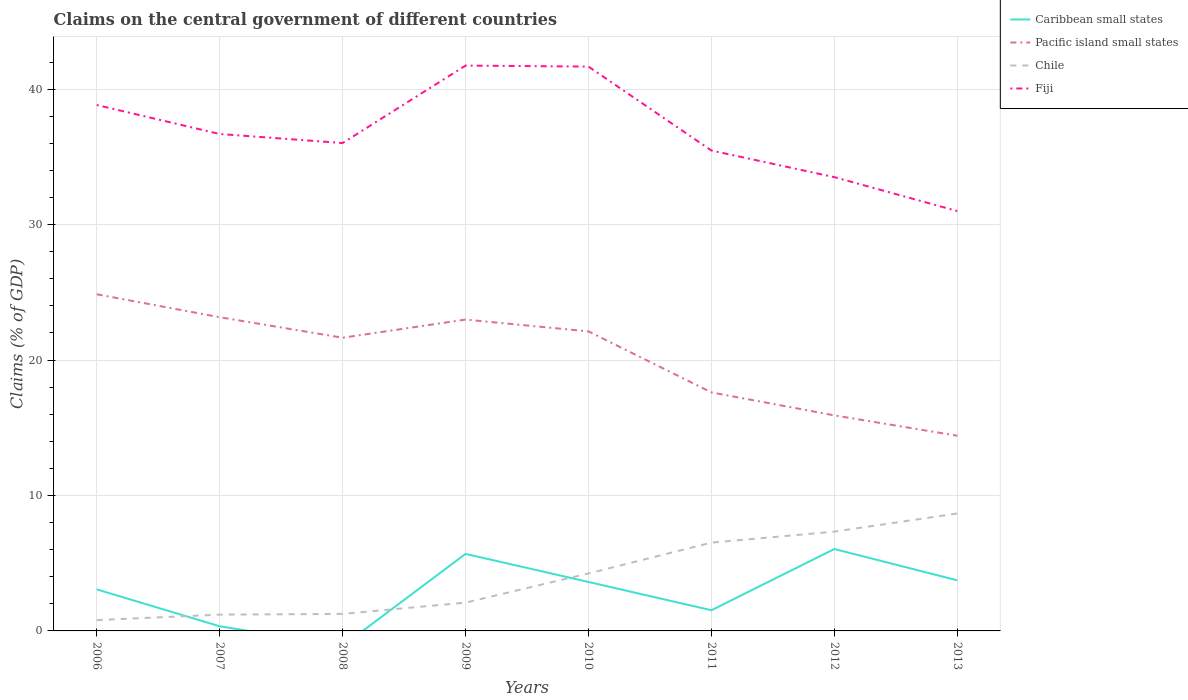Does the line corresponding to Pacific island small states intersect with the line corresponding to Caribbean small states?
Your response must be concise. No. Across all years, what is the maximum percentage of GDP claimed on the central government in Chile?
Your response must be concise. 0.8. What is the total percentage of GDP claimed on the central government in Chile in the graph?
Ensure brevity in your answer.  -6.13. What is the difference between the highest and the second highest percentage of GDP claimed on the central government in Caribbean small states?
Your answer should be compact. 6.05. How many lines are there?
Make the answer very short. 4. Are the values on the major ticks of Y-axis written in scientific E-notation?
Your answer should be very brief. No. Does the graph contain any zero values?
Provide a short and direct response. Yes. Where does the legend appear in the graph?
Your response must be concise. Top right. How many legend labels are there?
Offer a terse response. 4. What is the title of the graph?
Make the answer very short. Claims on the central government of different countries. Does "Iran" appear as one of the legend labels in the graph?
Offer a very short reply. No. What is the label or title of the Y-axis?
Your response must be concise. Claims (% of GDP). What is the Claims (% of GDP) in Caribbean small states in 2006?
Make the answer very short. 3.07. What is the Claims (% of GDP) of Pacific island small states in 2006?
Your answer should be compact. 24.86. What is the Claims (% of GDP) of Chile in 2006?
Provide a short and direct response. 0.8. What is the Claims (% of GDP) in Fiji in 2006?
Give a very brief answer. 38.83. What is the Claims (% of GDP) in Caribbean small states in 2007?
Your response must be concise. 0.34. What is the Claims (% of GDP) of Pacific island small states in 2007?
Make the answer very short. 23.16. What is the Claims (% of GDP) of Chile in 2007?
Provide a short and direct response. 1.2. What is the Claims (% of GDP) in Fiji in 2007?
Give a very brief answer. 36.69. What is the Claims (% of GDP) of Caribbean small states in 2008?
Your answer should be compact. 0. What is the Claims (% of GDP) in Pacific island small states in 2008?
Give a very brief answer. 21.65. What is the Claims (% of GDP) in Chile in 2008?
Ensure brevity in your answer.  1.26. What is the Claims (% of GDP) in Fiji in 2008?
Make the answer very short. 36.02. What is the Claims (% of GDP) in Caribbean small states in 2009?
Make the answer very short. 5.69. What is the Claims (% of GDP) in Pacific island small states in 2009?
Provide a succinct answer. 22.99. What is the Claims (% of GDP) in Chile in 2009?
Ensure brevity in your answer.  2.09. What is the Claims (% of GDP) of Fiji in 2009?
Your answer should be very brief. 41.74. What is the Claims (% of GDP) in Caribbean small states in 2010?
Your answer should be very brief. 3.61. What is the Claims (% of GDP) in Pacific island small states in 2010?
Offer a terse response. 22.12. What is the Claims (% of GDP) of Chile in 2010?
Make the answer very short. 4.24. What is the Claims (% of GDP) of Fiji in 2010?
Make the answer very short. 41.67. What is the Claims (% of GDP) of Caribbean small states in 2011?
Ensure brevity in your answer.  1.53. What is the Claims (% of GDP) in Pacific island small states in 2011?
Ensure brevity in your answer.  17.61. What is the Claims (% of GDP) in Chile in 2011?
Ensure brevity in your answer.  6.52. What is the Claims (% of GDP) in Fiji in 2011?
Provide a short and direct response. 35.47. What is the Claims (% of GDP) of Caribbean small states in 2012?
Your answer should be compact. 6.05. What is the Claims (% of GDP) of Pacific island small states in 2012?
Provide a short and direct response. 15.92. What is the Claims (% of GDP) in Chile in 2012?
Your answer should be very brief. 7.33. What is the Claims (% of GDP) in Fiji in 2012?
Your answer should be compact. 33.51. What is the Claims (% of GDP) in Caribbean small states in 2013?
Give a very brief answer. 3.74. What is the Claims (% of GDP) of Pacific island small states in 2013?
Ensure brevity in your answer.  14.41. What is the Claims (% of GDP) of Chile in 2013?
Ensure brevity in your answer.  8.67. What is the Claims (% of GDP) in Fiji in 2013?
Ensure brevity in your answer.  31. Across all years, what is the maximum Claims (% of GDP) in Caribbean small states?
Your answer should be very brief. 6.05. Across all years, what is the maximum Claims (% of GDP) of Pacific island small states?
Offer a very short reply. 24.86. Across all years, what is the maximum Claims (% of GDP) of Chile?
Provide a succinct answer. 8.67. Across all years, what is the maximum Claims (% of GDP) in Fiji?
Provide a succinct answer. 41.74. Across all years, what is the minimum Claims (% of GDP) of Pacific island small states?
Provide a succinct answer. 14.41. Across all years, what is the minimum Claims (% of GDP) of Chile?
Offer a terse response. 0.8. Across all years, what is the minimum Claims (% of GDP) of Fiji?
Provide a short and direct response. 31. What is the total Claims (% of GDP) in Caribbean small states in the graph?
Give a very brief answer. 24.02. What is the total Claims (% of GDP) in Pacific island small states in the graph?
Keep it short and to the point. 162.72. What is the total Claims (% of GDP) in Chile in the graph?
Offer a terse response. 32.12. What is the total Claims (% of GDP) in Fiji in the graph?
Your response must be concise. 294.95. What is the difference between the Claims (% of GDP) in Caribbean small states in 2006 and that in 2007?
Keep it short and to the point. 2.73. What is the difference between the Claims (% of GDP) of Pacific island small states in 2006 and that in 2007?
Keep it short and to the point. 1.69. What is the difference between the Claims (% of GDP) of Chile in 2006 and that in 2007?
Give a very brief answer. -0.41. What is the difference between the Claims (% of GDP) in Fiji in 2006 and that in 2007?
Make the answer very short. 2.14. What is the difference between the Claims (% of GDP) of Pacific island small states in 2006 and that in 2008?
Offer a very short reply. 3.21. What is the difference between the Claims (% of GDP) in Chile in 2006 and that in 2008?
Offer a very short reply. -0.46. What is the difference between the Claims (% of GDP) of Fiji in 2006 and that in 2008?
Make the answer very short. 2.81. What is the difference between the Claims (% of GDP) of Caribbean small states in 2006 and that in 2009?
Offer a terse response. -2.62. What is the difference between the Claims (% of GDP) of Pacific island small states in 2006 and that in 2009?
Offer a terse response. 1.87. What is the difference between the Claims (% of GDP) of Chile in 2006 and that in 2009?
Offer a terse response. -1.29. What is the difference between the Claims (% of GDP) of Fiji in 2006 and that in 2009?
Offer a terse response. -2.91. What is the difference between the Claims (% of GDP) of Caribbean small states in 2006 and that in 2010?
Your answer should be compact. -0.55. What is the difference between the Claims (% of GDP) of Pacific island small states in 2006 and that in 2010?
Give a very brief answer. 2.74. What is the difference between the Claims (% of GDP) in Chile in 2006 and that in 2010?
Keep it short and to the point. -3.45. What is the difference between the Claims (% of GDP) in Fiji in 2006 and that in 2010?
Offer a very short reply. -2.84. What is the difference between the Claims (% of GDP) of Caribbean small states in 2006 and that in 2011?
Your answer should be very brief. 1.54. What is the difference between the Claims (% of GDP) in Pacific island small states in 2006 and that in 2011?
Offer a terse response. 7.25. What is the difference between the Claims (% of GDP) in Chile in 2006 and that in 2011?
Keep it short and to the point. -5.72. What is the difference between the Claims (% of GDP) in Fiji in 2006 and that in 2011?
Provide a succinct answer. 3.36. What is the difference between the Claims (% of GDP) in Caribbean small states in 2006 and that in 2012?
Your answer should be compact. -2.98. What is the difference between the Claims (% of GDP) in Pacific island small states in 2006 and that in 2012?
Keep it short and to the point. 8.94. What is the difference between the Claims (% of GDP) of Chile in 2006 and that in 2012?
Offer a terse response. -6.53. What is the difference between the Claims (% of GDP) of Fiji in 2006 and that in 2012?
Keep it short and to the point. 5.33. What is the difference between the Claims (% of GDP) of Caribbean small states in 2006 and that in 2013?
Your answer should be compact. -0.67. What is the difference between the Claims (% of GDP) in Pacific island small states in 2006 and that in 2013?
Provide a succinct answer. 10.44. What is the difference between the Claims (% of GDP) in Chile in 2006 and that in 2013?
Offer a very short reply. -7.87. What is the difference between the Claims (% of GDP) of Fiji in 2006 and that in 2013?
Provide a succinct answer. 7.83. What is the difference between the Claims (% of GDP) of Pacific island small states in 2007 and that in 2008?
Keep it short and to the point. 1.52. What is the difference between the Claims (% of GDP) in Chile in 2007 and that in 2008?
Your answer should be compact. -0.05. What is the difference between the Claims (% of GDP) of Fiji in 2007 and that in 2008?
Ensure brevity in your answer.  0.67. What is the difference between the Claims (% of GDP) of Caribbean small states in 2007 and that in 2009?
Make the answer very short. -5.35. What is the difference between the Claims (% of GDP) of Pacific island small states in 2007 and that in 2009?
Give a very brief answer. 0.17. What is the difference between the Claims (% of GDP) in Chile in 2007 and that in 2009?
Ensure brevity in your answer.  -0.89. What is the difference between the Claims (% of GDP) of Fiji in 2007 and that in 2009?
Your answer should be compact. -5.05. What is the difference between the Claims (% of GDP) of Caribbean small states in 2007 and that in 2010?
Make the answer very short. -3.27. What is the difference between the Claims (% of GDP) in Pacific island small states in 2007 and that in 2010?
Your answer should be compact. 1.05. What is the difference between the Claims (% of GDP) in Chile in 2007 and that in 2010?
Provide a short and direct response. -3.04. What is the difference between the Claims (% of GDP) in Fiji in 2007 and that in 2010?
Your answer should be compact. -4.98. What is the difference between the Claims (% of GDP) in Caribbean small states in 2007 and that in 2011?
Your answer should be very brief. -1.19. What is the difference between the Claims (% of GDP) of Pacific island small states in 2007 and that in 2011?
Provide a succinct answer. 5.55. What is the difference between the Claims (% of GDP) in Chile in 2007 and that in 2011?
Offer a terse response. -5.32. What is the difference between the Claims (% of GDP) in Fiji in 2007 and that in 2011?
Provide a succinct answer. 1.22. What is the difference between the Claims (% of GDP) in Caribbean small states in 2007 and that in 2012?
Offer a terse response. -5.71. What is the difference between the Claims (% of GDP) in Pacific island small states in 2007 and that in 2012?
Keep it short and to the point. 7.25. What is the difference between the Claims (% of GDP) in Chile in 2007 and that in 2012?
Your answer should be very brief. -6.13. What is the difference between the Claims (% of GDP) of Fiji in 2007 and that in 2012?
Keep it short and to the point. 3.19. What is the difference between the Claims (% of GDP) in Caribbean small states in 2007 and that in 2013?
Ensure brevity in your answer.  -3.39. What is the difference between the Claims (% of GDP) in Pacific island small states in 2007 and that in 2013?
Provide a short and direct response. 8.75. What is the difference between the Claims (% of GDP) of Chile in 2007 and that in 2013?
Ensure brevity in your answer.  -7.47. What is the difference between the Claims (% of GDP) in Fiji in 2007 and that in 2013?
Your answer should be very brief. 5.69. What is the difference between the Claims (% of GDP) of Pacific island small states in 2008 and that in 2009?
Offer a terse response. -1.34. What is the difference between the Claims (% of GDP) in Chile in 2008 and that in 2009?
Offer a terse response. -0.83. What is the difference between the Claims (% of GDP) of Fiji in 2008 and that in 2009?
Keep it short and to the point. -5.72. What is the difference between the Claims (% of GDP) in Pacific island small states in 2008 and that in 2010?
Keep it short and to the point. -0.47. What is the difference between the Claims (% of GDP) in Chile in 2008 and that in 2010?
Your response must be concise. -2.99. What is the difference between the Claims (% of GDP) in Fiji in 2008 and that in 2010?
Your answer should be very brief. -5.65. What is the difference between the Claims (% of GDP) in Pacific island small states in 2008 and that in 2011?
Keep it short and to the point. 4.04. What is the difference between the Claims (% of GDP) of Chile in 2008 and that in 2011?
Offer a very short reply. -5.26. What is the difference between the Claims (% of GDP) in Fiji in 2008 and that in 2011?
Keep it short and to the point. 0.55. What is the difference between the Claims (% of GDP) in Pacific island small states in 2008 and that in 2012?
Keep it short and to the point. 5.73. What is the difference between the Claims (% of GDP) in Chile in 2008 and that in 2012?
Ensure brevity in your answer.  -6.07. What is the difference between the Claims (% of GDP) in Fiji in 2008 and that in 2012?
Offer a very short reply. 2.52. What is the difference between the Claims (% of GDP) of Pacific island small states in 2008 and that in 2013?
Ensure brevity in your answer.  7.24. What is the difference between the Claims (% of GDP) in Chile in 2008 and that in 2013?
Provide a succinct answer. -7.41. What is the difference between the Claims (% of GDP) in Fiji in 2008 and that in 2013?
Provide a succinct answer. 5.02. What is the difference between the Claims (% of GDP) of Caribbean small states in 2009 and that in 2010?
Make the answer very short. 2.07. What is the difference between the Claims (% of GDP) of Pacific island small states in 2009 and that in 2010?
Keep it short and to the point. 0.87. What is the difference between the Claims (% of GDP) in Chile in 2009 and that in 2010?
Provide a succinct answer. -2.15. What is the difference between the Claims (% of GDP) in Fiji in 2009 and that in 2010?
Your answer should be compact. 0.07. What is the difference between the Claims (% of GDP) of Caribbean small states in 2009 and that in 2011?
Keep it short and to the point. 4.16. What is the difference between the Claims (% of GDP) of Pacific island small states in 2009 and that in 2011?
Provide a succinct answer. 5.38. What is the difference between the Claims (% of GDP) in Chile in 2009 and that in 2011?
Keep it short and to the point. -4.43. What is the difference between the Claims (% of GDP) in Fiji in 2009 and that in 2011?
Keep it short and to the point. 6.27. What is the difference between the Claims (% of GDP) of Caribbean small states in 2009 and that in 2012?
Offer a terse response. -0.36. What is the difference between the Claims (% of GDP) in Pacific island small states in 2009 and that in 2012?
Ensure brevity in your answer.  7.07. What is the difference between the Claims (% of GDP) of Chile in 2009 and that in 2012?
Your answer should be very brief. -5.24. What is the difference between the Claims (% of GDP) in Fiji in 2009 and that in 2012?
Your response must be concise. 8.24. What is the difference between the Claims (% of GDP) of Caribbean small states in 2009 and that in 2013?
Give a very brief answer. 1.95. What is the difference between the Claims (% of GDP) in Pacific island small states in 2009 and that in 2013?
Make the answer very short. 8.58. What is the difference between the Claims (% of GDP) of Chile in 2009 and that in 2013?
Provide a succinct answer. -6.58. What is the difference between the Claims (% of GDP) in Fiji in 2009 and that in 2013?
Offer a terse response. 10.74. What is the difference between the Claims (% of GDP) of Caribbean small states in 2010 and that in 2011?
Offer a very short reply. 2.09. What is the difference between the Claims (% of GDP) in Pacific island small states in 2010 and that in 2011?
Give a very brief answer. 4.5. What is the difference between the Claims (% of GDP) in Chile in 2010 and that in 2011?
Keep it short and to the point. -2.28. What is the difference between the Claims (% of GDP) of Fiji in 2010 and that in 2011?
Provide a short and direct response. 6.2. What is the difference between the Claims (% of GDP) in Caribbean small states in 2010 and that in 2012?
Your response must be concise. -2.43. What is the difference between the Claims (% of GDP) of Pacific island small states in 2010 and that in 2012?
Your answer should be very brief. 6.2. What is the difference between the Claims (% of GDP) in Chile in 2010 and that in 2012?
Offer a terse response. -3.09. What is the difference between the Claims (% of GDP) of Fiji in 2010 and that in 2012?
Provide a succinct answer. 8.16. What is the difference between the Claims (% of GDP) of Caribbean small states in 2010 and that in 2013?
Give a very brief answer. -0.12. What is the difference between the Claims (% of GDP) in Pacific island small states in 2010 and that in 2013?
Ensure brevity in your answer.  7.7. What is the difference between the Claims (% of GDP) of Chile in 2010 and that in 2013?
Offer a very short reply. -4.43. What is the difference between the Claims (% of GDP) of Fiji in 2010 and that in 2013?
Provide a short and direct response. 10.67. What is the difference between the Claims (% of GDP) of Caribbean small states in 2011 and that in 2012?
Your response must be concise. -4.52. What is the difference between the Claims (% of GDP) in Pacific island small states in 2011 and that in 2012?
Offer a very short reply. 1.7. What is the difference between the Claims (% of GDP) of Chile in 2011 and that in 2012?
Your answer should be compact. -0.81. What is the difference between the Claims (% of GDP) in Fiji in 2011 and that in 2012?
Ensure brevity in your answer.  1.97. What is the difference between the Claims (% of GDP) of Caribbean small states in 2011 and that in 2013?
Offer a very short reply. -2.21. What is the difference between the Claims (% of GDP) of Pacific island small states in 2011 and that in 2013?
Provide a short and direct response. 3.2. What is the difference between the Claims (% of GDP) in Chile in 2011 and that in 2013?
Make the answer very short. -2.15. What is the difference between the Claims (% of GDP) in Fiji in 2011 and that in 2013?
Give a very brief answer. 4.47. What is the difference between the Claims (% of GDP) of Caribbean small states in 2012 and that in 2013?
Keep it short and to the point. 2.31. What is the difference between the Claims (% of GDP) of Pacific island small states in 2012 and that in 2013?
Make the answer very short. 1.5. What is the difference between the Claims (% of GDP) in Chile in 2012 and that in 2013?
Provide a short and direct response. -1.34. What is the difference between the Claims (% of GDP) in Fiji in 2012 and that in 2013?
Your answer should be compact. 2.5. What is the difference between the Claims (% of GDP) in Caribbean small states in 2006 and the Claims (% of GDP) in Pacific island small states in 2007?
Give a very brief answer. -20.1. What is the difference between the Claims (% of GDP) in Caribbean small states in 2006 and the Claims (% of GDP) in Chile in 2007?
Provide a short and direct response. 1.86. What is the difference between the Claims (% of GDP) in Caribbean small states in 2006 and the Claims (% of GDP) in Fiji in 2007?
Offer a very short reply. -33.63. What is the difference between the Claims (% of GDP) of Pacific island small states in 2006 and the Claims (% of GDP) of Chile in 2007?
Offer a very short reply. 23.65. What is the difference between the Claims (% of GDP) of Pacific island small states in 2006 and the Claims (% of GDP) of Fiji in 2007?
Keep it short and to the point. -11.84. What is the difference between the Claims (% of GDP) in Chile in 2006 and the Claims (% of GDP) in Fiji in 2007?
Your response must be concise. -35.9. What is the difference between the Claims (% of GDP) in Caribbean small states in 2006 and the Claims (% of GDP) in Pacific island small states in 2008?
Give a very brief answer. -18.58. What is the difference between the Claims (% of GDP) in Caribbean small states in 2006 and the Claims (% of GDP) in Chile in 2008?
Offer a very short reply. 1.81. What is the difference between the Claims (% of GDP) of Caribbean small states in 2006 and the Claims (% of GDP) of Fiji in 2008?
Your response must be concise. -32.96. What is the difference between the Claims (% of GDP) in Pacific island small states in 2006 and the Claims (% of GDP) in Chile in 2008?
Your answer should be very brief. 23.6. What is the difference between the Claims (% of GDP) in Pacific island small states in 2006 and the Claims (% of GDP) in Fiji in 2008?
Provide a short and direct response. -11.17. What is the difference between the Claims (% of GDP) of Chile in 2006 and the Claims (% of GDP) of Fiji in 2008?
Give a very brief answer. -35.23. What is the difference between the Claims (% of GDP) of Caribbean small states in 2006 and the Claims (% of GDP) of Pacific island small states in 2009?
Give a very brief answer. -19.92. What is the difference between the Claims (% of GDP) in Caribbean small states in 2006 and the Claims (% of GDP) in Chile in 2009?
Ensure brevity in your answer.  0.98. What is the difference between the Claims (% of GDP) of Caribbean small states in 2006 and the Claims (% of GDP) of Fiji in 2009?
Offer a terse response. -38.68. What is the difference between the Claims (% of GDP) in Pacific island small states in 2006 and the Claims (% of GDP) in Chile in 2009?
Offer a very short reply. 22.77. What is the difference between the Claims (% of GDP) of Pacific island small states in 2006 and the Claims (% of GDP) of Fiji in 2009?
Make the answer very short. -16.89. What is the difference between the Claims (% of GDP) of Chile in 2006 and the Claims (% of GDP) of Fiji in 2009?
Your answer should be very brief. -40.95. What is the difference between the Claims (% of GDP) of Caribbean small states in 2006 and the Claims (% of GDP) of Pacific island small states in 2010?
Provide a succinct answer. -19.05. What is the difference between the Claims (% of GDP) of Caribbean small states in 2006 and the Claims (% of GDP) of Chile in 2010?
Ensure brevity in your answer.  -1.18. What is the difference between the Claims (% of GDP) of Caribbean small states in 2006 and the Claims (% of GDP) of Fiji in 2010?
Your response must be concise. -38.6. What is the difference between the Claims (% of GDP) of Pacific island small states in 2006 and the Claims (% of GDP) of Chile in 2010?
Your answer should be very brief. 20.61. What is the difference between the Claims (% of GDP) of Pacific island small states in 2006 and the Claims (% of GDP) of Fiji in 2010?
Ensure brevity in your answer.  -16.81. What is the difference between the Claims (% of GDP) of Chile in 2006 and the Claims (% of GDP) of Fiji in 2010?
Give a very brief answer. -40.87. What is the difference between the Claims (% of GDP) in Caribbean small states in 2006 and the Claims (% of GDP) in Pacific island small states in 2011?
Offer a terse response. -14.54. What is the difference between the Claims (% of GDP) in Caribbean small states in 2006 and the Claims (% of GDP) in Chile in 2011?
Provide a succinct answer. -3.45. What is the difference between the Claims (% of GDP) of Caribbean small states in 2006 and the Claims (% of GDP) of Fiji in 2011?
Offer a terse response. -32.41. What is the difference between the Claims (% of GDP) of Pacific island small states in 2006 and the Claims (% of GDP) of Chile in 2011?
Give a very brief answer. 18.34. What is the difference between the Claims (% of GDP) of Pacific island small states in 2006 and the Claims (% of GDP) of Fiji in 2011?
Provide a succinct answer. -10.62. What is the difference between the Claims (% of GDP) in Chile in 2006 and the Claims (% of GDP) in Fiji in 2011?
Your response must be concise. -34.67. What is the difference between the Claims (% of GDP) of Caribbean small states in 2006 and the Claims (% of GDP) of Pacific island small states in 2012?
Provide a short and direct response. -12.85. What is the difference between the Claims (% of GDP) in Caribbean small states in 2006 and the Claims (% of GDP) in Chile in 2012?
Offer a terse response. -4.26. What is the difference between the Claims (% of GDP) in Caribbean small states in 2006 and the Claims (% of GDP) in Fiji in 2012?
Make the answer very short. -30.44. What is the difference between the Claims (% of GDP) of Pacific island small states in 2006 and the Claims (% of GDP) of Chile in 2012?
Provide a short and direct response. 17.53. What is the difference between the Claims (% of GDP) in Pacific island small states in 2006 and the Claims (% of GDP) in Fiji in 2012?
Your answer should be compact. -8.65. What is the difference between the Claims (% of GDP) of Chile in 2006 and the Claims (% of GDP) of Fiji in 2012?
Offer a very short reply. -32.71. What is the difference between the Claims (% of GDP) of Caribbean small states in 2006 and the Claims (% of GDP) of Pacific island small states in 2013?
Provide a succinct answer. -11.35. What is the difference between the Claims (% of GDP) in Caribbean small states in 2006 and the Claims (% of GDP) in Chile in 2013?
Keep it short and to the point. -5.6. What is the difference between the Claims (% of GDP) of Caribbean small states in 2006 and the Claims (% of GDP) of Fiji in 2013?
Provide a succinct answer. -27.94. What is the difference between the Claims (% of GDP) of Pacific island small states in 2006 and the Claims (% of GDP) of Chile in 2013?
Offer a very short reply. 16.19. What is the difference between the Claims (% of GDP) in Pacific island small states in 2006 and the Claims (% of GDP) in Fiji in 2013?
Keep it short and to the point. -6.15. What is the difference between the Claims (% of GDP) in Chile in 2006 and the Claims (% of GDP) in Fiji in 2013?
Provide a short and direct response. -30.21. What is the difference between the Claims (% of GDP) of Caribbean small states in 2007 and the Claims (% of GDP) of Pacific island small states in 2008?
Keep it short and to the point. -21.31. What is the difference between the Claims (% of GDP) of Caribbean small states in 2007 and the Claims (% of GDP) of Chile in 2008?
Your answer should be very brief. -0.92. What is the difference between the Claims (% of GDP) of Caribbean small states in 2007 and the Claims (% of GDP) of Fiji in 2008?
Provide a short and direct response. -35.68. What is the difference between the Claims (% of GDP) in Pacific island small states in 2007 and the Claims (% of GDP) in Chile in 2008?
Offer a very short reply. 21.91. What is the difference between the Claims (% of GDP) in Pacific island small states in 2007 and the Claims (% of GDP) in Fiji in 2008?
Give a very brief answer. -12.86. What is the difference between the Claims (% of GDP) of Chile in 2007 and the Claims (% of GDP) of Fiji in 2008?
Offer a very short reply. -34.82. What is the difference between the Claims (% of GDP) of Caribbean small states in 2007 and the Claims (% of GDP) of Pacific island small states in 2009?
Make the answer very short. -22.65. What is the difference between the Claims (% of GDP) of Caribbean small states in 2007 and the Claims (% of GDP) of Chile in 2009?
Your answer should be compact. -1.75. What is the difference between the Claims (% of GDP) in Caribbean small states in 2007 and the Claims (% of GDP) in Fiji in 2009?
Provide a succinct answer. -41.4. What is the difference between the Claims (% of GDP) in Pacific island small states in 2007 and the Claims (% of GDP) in Chile in 2009?
Your response must be concise. 21.07. What is the difference between the Claims (% of GDP) of Pacific island small states in 2007 and the Claims (% of GDP) of Fiji in 2009?
Make the answer very short. -18.58. What is the difference between the Claims (% of GDP) in Chile in 2007 and the Claims (% of GDP) in Fiji in 2009?
Your answer should be compact. -40.54. What is the difference between the Claims (% of GDP) of Caribbean small states in 2007 and the Claims (% of GDP) of Pacific island small states in 2010?
Provide a succinct answer. -21.78. What is the difference between the Claims (% of GDP) in Caribbean small states in 2007 and the Claims (% of GDP) in Chile in 2010?
Make the answer very short. -3.9. What is the difference between the Claims (% of GDP) in Caribbean small states in 2007 and the Claims (% of GDP) in Fiji in 2010?
Make the answer very short. -41.33. What is the difference between the Claims (% of GDP) in Pacific island small states in 2007 and the Claims (% of GDP) in Chile in 2010?
Offer a very short reply. 18.92. What is the difference between the Claims (% of GDP) in Pacific island small states in 2007 and the Claims (% of GDP) in Fiji in 2010?
Keep it short and to the point. -18.51. What is the difference between the Claims (% of GDP) in Chile in 2007 and the Claims (% of GDP) in Fiji in 2010?
Keep it short and to the point. -40.47. What is the difference between the Claims (% of GDP) of Caribbean small states in 2007 and the Claims (% of GDP) of Pacific island small states in 2011?
Ensure brevity in your answer.  -17.27. What is the difference between the Claims (% of GDP) of Caribbean small states in 2007 and the Claims (% of GDP) of Chile in 2011?
Offer a terse response. -6.18. What is the difference between the Claims (% of GDP) of Caribbean small states in 2007 and the Claims (% of GDP) of Fiji in 2011?
Your answer should be compact. -35.13. What is the difference between the Claims (% of GDP) in Pacific island small states in 2007 and the Claims (% of GDP) in Chile in 2011?
Provide a succinct answer. 16.64. What is the difference between the Claims (% of GDP) of Pacific island small states in 2007 and the Claims (% of GDP) of Fiji in 2011?
Your answer should be compact. -12.31. What is the difference between the Claims (% of GDP) in Chile in 2007 and the Claims (% of GDP) in Fiji in 2011?
Provide a short and direct response. -34.27. What is the difference between the Claims (% of GDP) of Caribbean small states in 2007 and the Claims (% of GDP) of Pacific island small states in 2012?
Your response must be concise. -15.57. What is the difference between the Claims (% of GDP) of Caribbean small states in 2007 and the Claims (% of GDP) of Chile in 2012?
Offer a terse response. -6.99. What is the difference between the Claims (% of GDP) in Caribbean small states in 2007 and the Claims (% of GDP) in Fiji in 2012?
Ensure brevity in your answer.  -33.16. What is the difference between the Claims (% of GDP) of Pacific island small states in 2007 and the Claims (% of GDP) of Chile in 2012?
Offer a very short reply. 15.83. What is the difference between the Claims (% of GDP) of Pacific island small states in 2007 and the Claims (% of GDP) of Fiji in 2012?
Make the answer very short. -10.34. What is the difference between the Claims (% of GDP) in Chile in 2007 and the Claims (% of GDP) in Fiji in 2012?
Provide a succinct answer. -32.3. What is the difference between the Claims (% of GDP) of Caribbean small states in 2007 and the Claims (% of GDP) of Pacific island small states in 2013?
Ensure brevity in your answer.  -14.07. What is the difference between the Claims (% of GDP) of Caribbean small states in 2007 and the Claims (% of GDP) of Chile in 2013?
Give a very brief answer. -8.33. What is the difference between the Claims (% of GDP) of Caribbean small states in 2007 and the Claims (% of GDP) of Fiji in 2013?
Provide a short and direct response. -30.66. What is the difference between the Claims (% of GDP) in Pacific island small states in 2007 and the Claims (% of GDP) in Chile in 2013?
Your response must be concise. 14.49. What is the difference between the Claims (% of GDP) of Pacific island small states in 2007 and the Claims (% of GDP) of Fiji in 2013?
Give a very brief answer. -7.84. What is the difference between the Claims (% of GDP) in Chile in 2007 and the Claims (% of GDP) in Fiji in 2013?
Give a very brief answer. -29.8. What is the difference between the Claims (% of GDP) of Pacific island small states in 2008 and the Claims (% of GDP) of Chile in 2009?
Your response must be concise. 19.56. What is the difference between the Claims (% of GDP) of Pacific island small states in 2008 and the Claims (% of GDP) of Fiji in 2009?
Your response must be concise. -20.1. What is the difference between the Claims (% of GDP) in Chile in 2008 and the Claims (% of GDP) in Fiji in 2009?
Provide a succinct answer. -40.49. What is the difference between the Claims (% of GDP) in Pacific island small states in 2008 and the Claims (% of GDP) in Chile in 2010?
Make the answer very short. 17.41. What is the difference between the Claims (% of GDP) in Pacific island small states in 2008 and the Claims (% of GDP) in Fiji in 2010?
Your response must be concise. -20.02. What is the difference between the Claims (% of GDP) in Chile in 2008 and the Claims (% of GDP) in Fiji in 2010?
Your answer should be very brief. -40.41. What is the difference between the Claims (% of GDP) of Pacific island small states in 2008 and the Claims (% of GDP) of Chile in 2011?
Offer a terse response. 15.13. What is the difference between the Claims (% of GDP) in Pacific island small states in 2008 and the Claims (% of GDP) in Fiji in 2011?
Keep it short and to the point. -13.82. What is the difference between the Claims (% of GDP) in Chile in 2008 and the Claims (% of GDP) in Fiji in 2011?
Offer a terse response. -34.22. What is the difference between the Claims (% of GDP) of Pacific island small states in 2008 and the Claims (% of GDP) of Chile in 2012?
Offer a very short reply. 14.32. What is the difference between the Claims (% of GDP) in Pacific island small states in 2008 and the Claims (% of GDP) in Fiji in 2012?
Offer a terse response. -11.86. What is the difference between the Claims (% of GDP) of Chile in 2008 and the Claims (% of GDP) of Fiji in 2012?
Ensure brevity in your answer.  -32.25. What is the difference between the Claims (% of GDP) of Pacific island small states in 2008 and the Claims (% of GDP) of Chile in 2013?
Make the answer very short. 12.98. What is the difference between the Claims (% of GDP) of Pacific island small states in 2008 and the Claims (% of GDP) of Fiji in 2013?
Provide a short and direct response. -9.35. What is the difference between the Claims (% of GDP) in Chile in 2008 and the Claims (% of GDP) in Fiji in 2013?
Provide a succinct answer. -29.75. What is the difference between the Claims (% of GDP) in Caribbean small states in 2009 and the Claims (% of GDP) in Pacific island small states in 2010?
Provide a succinct answer. -16.43. What is the difference between the Claims (% of GDP) of Caribbean small states in 2009 and the Claims (% of GDP) of Chile in 2010?
Your response must be concise. 1.45. What is the difference between the Claims (% of GDP) of Caribbean small states in 2009 and the Claims (% of GDP) of Fiji in 2010?
Your answer should be very brief. -35.98. What is the difference between the Claims (% of GDP) of Pacific island small states in 2009 and the Claims (% of GDP) of Chile in 2010?
Your answer should be compact. 18.75. What is the difference between the Claims (% of GDP) of Pacific island small states in 2009 and the Claims (% of GDP) of Fiji in 2010?
Give a very brief answer. -18.68. What is the difference between the Claims (% of GDP) of Chile in 2009 and the Claims (% of GDP) of Fiji in 2010?
Your answer should be very brief. -39.58. What is the difference between the Claims (% of GDP) of Caribbean small states in 2009 and the Claims (% of GDP) of Pacific island small states in 2011?
Your answer should be compact. -11.92. What is the difference between the Claims (% of GDP) in Caribbean small states in 2009 and the Claims (% of GDP) in Chile in 2011?
Provide a succinct answer. -0.83. What is the difference between the Claims (% of GDP) in Caribbean small states in 2009 and the Claims (% of GDP) in Fiji in 2011?
Provide a short and direct response. -29.78. What is the difference between the Claims (% of GDP) of Pacific island small states in 2009 and the Claims (% of GDP) of Chile in 2011?
Provide a short and direct response. 16.47. What is the difference between the Claims (% of GDP) of Pacific island small states in 2009 and the Claims (% of GDP) of Fiji in 2011?
Offer a terse response. -12.48. What is the difference between the Claims (% of GDP) in Chile in 2009 and the Claims (% of GDP) in Fiji in 2011?
Give a very brief answer. -33.38. What is the difference between the Claims (% of GDP) in Caribbean small states in 2009 and the Claims (% of GDP) in Pacific island small states in 2012?
Your response must be concise. -10.23. What is the difference between the Claims (% of GDP) of Caribbean small states in 2009 and the Claims (% of GDP) of Chile in 2012?
Provide a short and direct response. -1.64. What is the difference between the Claims (% of GDP) of Caribbean small states in 2009 and the Claims (% of GDP) of Fiji in 2012?
Make the answer very short. -27.82. What is the difference between the Claims (% of GDP) in Pacific island small states in 2009 and the Claims (% of GDP) in Chile in 2012?
Provide a succinct answer. 15.66. What is the difference between the Claims (% of GDP) of Pacific island small states in 2009 and the Claims (% of GDP) of Fiji in 2012?
Offer a terse response. -10.52. What is the difference between the Claims (% of GDP) in Chile in 2009 and the Claims (% of GDP) in Fiji in 2012?
Make the answer very short. -31.42. What is the difference between the Claims (% of GDP) of Caribbean small states in 2009 and the Claims (% of GDP) of Pacific island small states in 2013?
Provide a succinct answer. -8.73. What is the difference between the Claims (% of GDP) of Caribbean small states in 2009 and the Claims (% of GDP) of Chile in 2013?
Make the answer very short. -2.98. What is the difference between the Claims (% of GDP) of Caribbean small states in 2009 and the Claims (% of GDP) of Fiji in 2013?
Keep it short and to the point. -25.32. What is the difference between the Claims (% of GDP) of Pacific island small states in 2009 and the Claims (% of GDP) of Chile in 2013?
Your answer should be very brief. 14.32. What is the difference between the Claims (% of GDP) of Pacific island small states in 2009 and the Claims (% of GDP) of Fiji in 2013?
Your answer should be very brief. -8.01. What is the difference between the Claims (% of GDP) of Chile in 2009 and the Claims (% of GDP) of Fiji in 2013?
Ensure brevity in your answer.  -28.91. What is the difference between the Claims (% of GDP) of Caribbean small states in 2010 and the Claims (% of GDP) of Pacific island small states in 2011?
Provide a short and direct response. -14. What is the difference between the Claims (% of GDP) of Caribbean small states in 2010 and the Claims (% of GDP) of Chile in 2011?
Give a very brief answer. -2.91. What is the difference between the Claims (% of GDP) in Caribbean small states in 2010 and the Claims (% of GDP) in Fiji in 2011?
Your answer should be very brief. -31.86. What is the difference between the Claims (% of GDP) of Pacific island small states in 2010 and the Claims (% of GDP) of Chile in 2011?
Offer a terse response. 15.6. What is the difference between the Claims (% of GDP) of Pacific island small states in 2010 and the Claims (% of GDP) of Fiji in 2011?
Offer a very short reply. -13.36. What is the difference between the Claims (% of GDP) of Chile in 2010 and the Claims (% of GDP) of Fiji in 2011?
Provide a succinct answer. -31.23. What is the difference between the Claims (% of GDP) of Caribbean small states in 2010 and the Claims (% of GDP) of Pacific island small states in 2012?
Keep it short and to the point. -12.3. What is the difference between the Claims (% of GDP) in Caribbean small states in 2010 and the Claims (% of GDP) in Chile in 2012?
Provide a short and direct response. -3.72. What is the difference between the Claims (% of GDP) in Caribbean small states in 2010 and the Claims (% of GDP) in Fiji in 2012?
Provide a short and direct response. -29.89. What is the difference between the Claims (% of GDP) of Pacific island small states in 2010 and the Claims (% of GDP) of Chile in 2012?
Keep it short and to the point. 14.79. What is the difference between the Claims (% of GDP) in Pacific island small states in 2010 and the Claims (% of GDP) in Fiji in 2012?
Offer a terse response. -11.39. What is the difference between the Claims (% of GDP) in Chile in 2010 and the Claims (% of GDP) in Fiji in 2012?
Ensure brevity in your answer.  -29.26. What is the difference between the Claims (% of GDP) in Caribbean small states in 2010 and the Claims (% of GDP) in Pacific island small states in 2013?
Offer a very short reply. -10.8. What is the difference between the Claims (% of GDP) in Caribbean small states in 2010 and the Claims (% of GDP) in Chile in 2013?
Keep it short and to the point. -5.06. What is the difference between the Claims (% of GDP) of Caribbean small states in 2010 and the Claims (% of GDP) of Fiji in 2013?
Offer a very short reply. -27.39. What is the difference between the Claims (% of GDP) in Pacific island small states in 2010 and the Claims (% of GDP) in Chile in 2013?
Keep it short and to the point. 13.45. What is the difference between the Claims (% of GDP) in Pacific island small states in 2010 and the Claims (% of GDP) in Fiji in 2013?
Your response must be concise. -8.89. What is the difference between the Claims (% of GDP) of Chile in 2010 and the Claims (% of GDP) of Fiji in 2013?
Offer a terse response. -26.76. What is the difference between the Claims (% of GDP) of Caribbean small states in 2011 and the Claims (% of GDP) of Pacific island small states in 2012?
Make the answer very short. -14.39. What is the difference between the Claims (% of GDP) of Caribbean small states in 2011 and the Claims (% of GDP) of Chile in 2012?
Provide a short and direct response. -5.81. What is the difference between the Claims (% of GDP) of Caribbean small states in 2011 and the Claims (% of GDP) of Fiji in 2012?
Offer a very short reply. -31.98. What is the difference between the Claims (% of GDP) of Pacific island small states in 2011 and the Claims (% of GDP) of Chile in 2012?
Your answer should be very brief. 10.28. What is the difference between the Claims (% of GDP) in Pacific island small states in 2011 and the Claims (% of GDP) in Fiji in 2012?
Give a very brief answer. -15.89. What is the difference between the Claims (% of GDP) in Chile in 2011 and the Claims (% of GDP) in Fiji in 2012?
Provide a short and direct response. -26.99. What is the difference between the Claims (% of GDP) in Caribbean small states in 2011 and the Claims (% of GDP) in Pacific island small states in 2013?
Your answer should be very brief. -12.89. What is the difference between the Claims (% of GDP) in Caribbean small states in 2011 and the Claims (% of GDP) in Chile in 2013?
Provide a succinct answer. -7.14. What is the difference between the Claims (% of GDP) in Caribbean small states in 2011 and the Claims (% of GDP) in Fiji in 2013?
Your response must be concise. -29.48. What is the difference between the Claims (% of GDP) of Pacific island small states in 2011 and the Claims (% of GDP) of Chile in 2013?
Offer a terse response. 8.94. What is the difference between the Claims (% of GDP) of Pacific island small states in 2011 and the Claims (% of GDP) of Fiji in 2013?
Keep it short and to the point. -13.39. What is the difference between the Claims (% of GDP) in Chile in 2011 and the Claims (% of GDP) in Fiji in 2013?
Provide a short and direct response. -24.48. What is the difference between the Claims (% of GDP) of Caribbean small states in 2012 and the Claims (% of GDP) of Pacific island small states in 2013?
Give a very brief answer. -8.37. What is the difference between the Claims (% of GDP) in Caribbean small states in 2012 and the Claims (% of GDP) in Chile in 2013?
Make the answer very short. -2.62. What is the difference between the Claims (% of GDP) of Caribbean small states in 2012 and the Claims (% of GDP) of Fiji in 2013?
Provide a succinct answer. -24.96. What is the difference between the Claims (% of GDP) of Pacific island small states in 2012 and the Claims (% of GDP) of Chile in 2013?
Ensure brevity in your answer.  7.24. What is the difference between the Claims (% of GDP) of Pacific island small states in 2012 and the Claims (% of GDP) of Fiji in 2013?
Keep it short and to the point. -15.09. What is the difference between the Claims (% of GDP) in Chile in 2012 and the Claims (% of GDP) in Fiji in 2013?
Give a very brief answer. -23.67. What is the average Claims (% of GDP) in Caribbean small states per year?
Make the answer very short. 3. What is the average Claims (% of GDP) of Pacific island small states per year?
Give a very brief answer. 20.34. What is the average Claims (% of GDP) in Chile per year?
Ensure brevity in your answer.  4.01. What is the average Claims (% of GDP) of Fiji per year?
Give a very brief answer. 36.87. In the year 2006, what is the difference between the Claims (% of GDP) of Caribbean small states and Claims (% of GDP) of Pacific island small states?
Keep it short and to the point. -21.79. In the year 2006, what is the difference between the Claims (% of GDP) in Caribbean small states and Claims (% of GDP) in Chile?
Make the answer very short. 2.27. In the year 2006, what is the difference between the Claims (% of GDP) in Caribbean small states and Claims (% of GDP) in Fiji?
Offer a very short reply. -35.77. In the year 2006, what is the difference between the Claims (% of GDP) of Pacific island small states and Claims (% of GDP) of Chile?
Provide a short and direct response. 24.06. In the year 2006, what is the difference between the Claims (% of GDP) of Pacific island small states and Claims (% of GDP) of Fiji?
Your answer should be compact. -13.98. In the year 2006, what is the difference between the Claims (% of GDP) of Chile and Claims (% of GDP) of Fiji?
Provide a succinct answer. -38.04. In the year 2007, what is the difference between the Claims (% of GDP) of Caribbean small states and Claims (% of GDP) of Pacific island small states?
Provide a short and direct response. -22.82. In the year 2007, what is the difference between the Claims (% of GDP) of Caribbean small states and Claims (% of GDP) of Chile?
Make the answer very short. -0.86. In the year 2007, what is the difference between the Claims (% of GDP) in Caribbean small states and Claims (% of GDP) in Fiji?
Offer a terse response. -36.35. In the year 2007, what is the difference between the Claims (% of GDP) in Pacific island small states and Claims (% of GDP) in Chile?
Offer a very short reply. 21.96. In the year 2007, what is the difference between the Claims (% of GDP) in Pacific island small states and Claims (% of GDP) in Fiji?
Your response must be concise. -13.53. In the year 2007, what is the difference between the Claims (% of GDP) in Chile and Claims (% of GDP) in Fiji?
Keep it short and to the point. -35.49. In the year 2008, what is the difference between the Claims (% of GDP) in Pacific island small states and Claims (% of GDP) in Chile?
Make the answer very short. 20.39. In the year 2008, what is the difference between the Claims (% of GDP) of Pacific island small states and Claims (% of GDP) of Fiji?
Provide a short and direct response. -14.38. In the year 2008, what is the difference between the Claims (% of GDP) of Chile and Claims (% of GDP) of Fiji?
Offer a terse response. -34.77. In the year 2009, what is the difference between the Claims (% of GDP) of Caribbean small states and Claims (% of GDP) of Pacific island small states?
Give a very brief answer. -17.3. In the year 2009, what is the difference between the Claims (% of GDP) of Caribbean small states and Claims (% of GDP) of Chile?
Your answer should be compact. 3.6. In the year 2009, what is the difference between the Claims (% of GDP) in Caribbean small states and Claims (% of GDP) in Fiji?
Your response must be concise. -36.06. In the year 2009, what is the difference between the Claims (% of GDP) of Pacific island small states and Claims (% of GDP) of Chile?
Your answer should be compact. 20.9. In the year 2009, what is the difference between the Claims (% of GDP) of Pacific island small states and Claims (% of GDP) of Fiji?
Your response must be concise. -18.75. In the year 2009, what is the difference between the Claims (% of GDP) of Chile and Claims (% of GDP) of Fiji?
Your answer should be very brief. -39.65. In the year 2010, what is the difference between the Claims (% of GDP) in Caribbean small states and Claims (% of GDP) in Pacific island small states?
Offer a terse response. -18.5. In the year 2010, what is the difference between the Claims (% of GDP) in Caribbean small states and Claims (% of GDP) in Chile?
Your answer should be very brief. -0.63. In the year 2010, what is the difference between the Claims (% of GDP) of Caribbean small states and Claims (% of GDP) of Fiji?
Your response must be concise. -38.06. In the year 2010, what is the difference between the Claims (% of GDP) in Pacific island small states and Claims (% of GDP) in Chile?
Offer a very short reply. 17.87. In the year 2010, what is the difference between the Claims (% of GDP) of Pacific island small states and Claims (% of GDP) of Fiji?
Make the answer very short. -19.55. In the year 2010, what is the difference between the Claims (% of GDP) of Chile and Claims (% of GDP) of Fiji?
Provide a short and direct response. -37.43. In the year 2011, what is the difference between the Claims (% of GDP) in Caribbean small states and Claims (% of GDP) in Pacific island small states?
Provide a succinct answer. -16.09. In the year 2011, what is the difference between the Claims (% of GDP) of Caribbean small states and Claims (% of GDP) of Chile?
Ensure brevity in your answer.  -4.99. In the year 2011, what is the difference between the Claims (% of GDP) in Caribbean small states and Claims (% of GDP) in Fiji?
Your response must be concise. -33.95. In the year 2011, what is the difference between the Claims (% of GDP) of Pacific island small states and Claims (% of GDP) of Chile?
Ensure brevity in your answer.  11.09. In the year 2011, what is the difference between the Claims (% of GDP) of Pacific island small states and Claims (% of GDP) of Fiji?
Your answer should be very brief. -17.86. In the year 2011, what is the difference between the Claims (% of GDP) in Chile and Claims (% of GDP) in Fiji?
Offer a very short reply. -28.95. In the year 2012, what is the difference between the Claims (% of GDP) of Caribbean small states and Claims (% of GDP) of Pacific island small states?
Offer a very short reply. -9.87. In the year 2012, what is the difference between the Claims (% of GDP) of Caribbean small states and Claims (% of GDP) of Chile?
Your response must be concise. -1.28. In the year 2012, what is the difference between the Claims (% of GDP) in Caribbean small states and Claims (% of GDP) in Fiji?
Offer a very short reply. -27.46. In the year 2012, what is the difference between the Claims (% of GDP) in Pacific island small states and Claims (% of GDP) in Chile?
Offer a very short reply. 8.58. In the year 2012, what is the difference between the Claims (% of GDP) of Pacific island small states and Claims (% of GDP) of Fiji?
Your answer should be compact. -17.59. In the year 2012, what is the difference between the Claims (% of GDP) in Chile and Claims (% of GDP) in Fiji?
Your answer should be very brief. -26.17. In the year 2013, what is the difference between the Claims (% of GDP) of Caribbean small states and Claims (% of GDP) of Pacific island small states?
Make the answer very short. -10.68. In the year 2013, what is the difference between the Claims (% of GDP) in Caribbean small states and Claims (% of GDP) in Chile?
Your response must be concise. -4.94. In the year 2013, what is the difference between the Claims (% of GDP) of Caribbean small states and Claims (% of GDP) of Fiji?
Ensure brevity in your answer.  -27.27. In the year 2013, what is the difference between the Claims (% of GDP) in Pacific island small states and Claims (% of GDP) in Chile?
Your response must be concise. 5.74. In the year 2013, what is the difference between the Claims (% of GDP) of Pacific island small states and Claims (% of GDP) of Fiji?
Make the answer very short. -16.59. In the year 2013, what is the difference between the Claims (% of GDP) in Chile and Claims (% of GDP) in Fiji?
Give a very brief answer. -22.33. What is the ratio of the Claims (% of GDP) in Caribbean small states in 2006 to that in 2007?
Provide a short and direct response. 8.96. What is the ratio of the Claims (% of GDP) of Pacific island small states in 2006 to that in 2007?
Your answer should be compact. 1.07. What is the ratio of the Claims (% of GDP) in Chile in 2006 to that in 2007?
Your answer should be compact. 0.66. What is the ratio of the Claims (% of GDP) of Fiji in 2006 to that in 2007?
Provide a short and direct response. 1.06. What is the ratio of the Claims (% of GDP) of Pacific island small states in 2006 to that in 2008?
Give a very brief answer. 1.15. What is the ratio of the Claims (% of GDP) of Chile in 2006 to that in 2008?
Give a very brief answer. 0.63. What is the ratio of the Claims (% of GDP) of Fiji in 2006 to that in 2008?
Your response must be concise. 1.08. What is the ratio of the Claims (% of GDP) of Caribbean small states in 2006 to that in 2009?
Provide a short and direct response. 0.54. What is the ratio of the Claims (% of GDP) in Pacific island small states in 2006 to that in 2009?
Your response must be concise. 1.08. What is the ratio of the Claims (% of GDP) in Chile in 2006 to that in 2009?
Your answer should be compact. 0.38. What is the ratio of the Claims (% of GDP) in Fiji in 2006 to that in 2009?
Give a very brief answer. 0.93. What is the ratio of the Claims (% of GDP) in Caribbean small states in 2006 to that in 2010?
Your answer should be compact. 0.85. What is the ratio of the Claims (% of GDP) in Pacific island small states in 2006 to that in 2010?
Provide a succinct answer. 1.12. What is the ratio of the Claims (% of GDP) in Chile in 2006 to that in 2010?
Offer a very short reply. 0.19. What is the ratio of the Claims (% of GDP) in Fiji in 2006 to that in 2010?
Provide a short and direct response. 0.93. What is the ratio of the Claims (% of GDP) in Caribbean small states in 2006 to that in 2011?
Offer a very short reply. 2.01. What is the ratio of the Claims (% of GDP) of Pacific island small states in 2006 to that in 2011?
Make the answer very short. 1.41. What is the ratio of the Claims (% of GDP) of Chile in 2006 to that in 2011?
Make the answer very short. 0.12. What is the ratio of the Claims (% of GDP) of Fiji in 2006 to that in 2011?
Make the answer very short. 1.09. What is the ratio of the Claims (% of GDP) of Caribbean small states in 2006 to that in 2012?
Ensure brevity in your answer.  0.51. What is the ratio of the Claims (% of GDP) in Pacific island small states in 2006 to that in 2012?
Make the answer very short. 1.56. What is the ratio of the Claims (% of GDP) in Chile in 2006 to that in 2012?
Provide a succinct answer. 0.11. What is the ratio of the Claims (% of GDP) in Fiji in 2006 to that in 2012?
Provide a succinct answer. 1.16. What is the ratio of the Claims (% of GDP) of Caribbean small states in 2006 to that in 2013?
Offer a very short reply. 0.82. What is the ratio of the Claims (% of GDP) in Pacific island small states in 2006 to that in 2013?
Make the answer very short. 1.72. What is the ratio of the Claims (% of GDP) of Chile in 2006 to that in 2013?
Make the answer very short. 0.09. What is the ratio of the Claims (% of GDP) of Fiji in 2006 to that in 2013?
Your answer should be very brief. 1.25. What is the ratio of the Claims (% of GDP) of Pacific island small states in 2007 to that in 2008?
Your answer should be compact. 1.07. What is the ratio of the Claims (% of GDP) in Chile in 2007 to that in 2008?
Provide a short and direct response. 0.96. What is the ratio of the Claims (% of GDP) of Fiji in 2007 to that in 2008?
Provide a short and direct response. 1.02. What is the ratio of the Claims (% of GDP) of Caribbean small states in 2007 to that in 2009?
Keep it short and to the point. 0.06. What is the ratio of the Claims (% of GDP) in Pacific island small states in 2007 to that in 2009?
Offer a very short reply. 1.01. What is the ratio of the Claims (% of GDP) of Chile in 2007 to that in 2009?
Your answer should be very brief. 0.58. What is the ratio of the Claims (% of GDP) of Fiji in 2007 to that in 2009?
Keep it short and to the point. 0.88. What is the ratio of the Claims (% of GDP) in Caribbean small states in 2007 to that in 2010?
Give a very brief answer. 0.09. What is the ratio of the Claims (% of GDP) in Pacific island small states in 2007 to that in 2010?
Your answer should be very brief. 1.05. What is the ratio of the Claims (% of GDP) of Chile in 2007 to that in 2010?
Keep it short and to the point. 0.28. What is the ratio of the Claims (% of GDP) in Fiji in 2007 to that in 2010?
Keep it short and to the point. 0.88. What is the ratio of the Claims (% of GDP) of Caribbean small states in 2007 to that in 2011?
Ensure brevity in your answer.  0.22. What is the ratio of the Claims (% of GDP) of Pacific island small states in 2007 to that in 2011?
Your response must be concise. 1.32. What is the ratio of the Claims (% of GDP) in Chile in 2007 to that in 2011?
Your answer should be compact. 0.18. What is the ratio of the Claims (% of GDP) in Fiji in 2007 to that in 2011?
Keep it short and to the point. 1.03. What is the ratio of the Claims (% of GDP) in Caribbean small states in 2007 to that in 2012?
Provide a succinct answer. 0.06. What is the ratio of the Claims (% of GDP) in Pacific island small states in 2007 to that in 2012?
Your answer should be compact. 1.46. What is the ratio of the Claims (% of GDP) of Chile in 2007 to that in 2012?
Your answer should be very brief. 0.16. What is the ratio of the Claims (% of GDP) in Fiji in 2007 to that in 2012?
Your response must be concise. 1.1. What is the ratio of the Claims (% of GDP) in Caribbean small states in 2007 to that in 2013?
Provide a succinct answer. 0.09. What is the ratio of the Claims (% of GDP) in Pacific island small states in 2007 to that in 2013?
Offer a terse response. 1.61. What is the ratio of the Claims (% of GDP) of Chile in 2007 to that in 2013?
Ensure brevity in your answer.  0.14. What is the ratio of the Claims (% of GDP) of Fiji in 2007 to that in 2013?
Provide a succinct answer. 1.18. What is the ratio of the Claims (% of GDP) of Pacific island small states in 2008 to that in 2009?
Your answer should be very brief. 0.94. What is the ratio of the Claims (% of GDP) in Chile in 2008 to that in 2009?
Provide a short and direct response. 0.6. What is the ratio of the Claims (% of GDP) in Fiji in 2008 to that in 2009?
Provide a short and direct response. 0.86. What is the ratio of the Claims (% of GDP) in Pacific island small states in 2008 to that in 2010?
Provide a short and direct response. 0.98. What is the ratio of the Claims (% of GDP) in Chile in 2008 to that in 2010?
Your answer should be compact. 0.3. What is the ratio of the Claims (% of GDP) in Fiji in 2008 to that in 2010?
Give a very brief answer. 0.86. What is the ratio of the Claims (% of GDP) of Pacific island small states in 2008 to that in 2011?
Ensure brevity in your answer.  1.23. What is the ratio of the Claims (% of GDP) in Chile in 2008 to that in 2011?
Provide a short and direct response. 0.19. What is the ratio of the Claims (% of GDP) in Fiji in 2008 to that in 2011?
Keep it short and to the point. 1.02. What is the ratio of the Claims (% of GDP) of Pacific island small states in 2008 to that in 2012?
Your answer should be very brief. 1.36. What is the ratio of the Claims (% of GDP) of Chile in 2008 to that in 2012?
Keep it short and to the point. 0.17. What is the ratio of the Claims (% of GDP) of Fiji in 2008 to that in 2012?
Your response must be concise. 1.08. What is the ratio of the Claims (% of GDP) of Pacific island small states in 2008 to that in 2013?
Your response must be concise. 1.5. What is the ratio of the Claims (% of GDP) of Chile in 2008 to that in 2013?
Offer a very short reply. 0.14. What is the ratio of the Claims (% of GDP) in Fiji in 2008 to that in 2013?
Offer a terse response. 1.16. What is the ratio of the Claims (% of GDP) of Caribbean small states in 2009 to that in 2010?
Keep it short and to the point. 1.57. What is the ratio of the Claims (% of GDP) in Pacific island small states in 2009 to that in 2010?
Keep it short and to the point. 1.04. What is the ratio of the Claims (% of GDP) in Chile in 2009 to that in 2010?
Make the answer very short. 0.49. What is the ratio of the Claims (% of GDP) of Fiji in 2009 to that in 2010?
Keep it short and to the point. 1. What is the ratio of the Claims (% of GDP) in Caribbean small states in 2009 to that in 2011?
Provide a short and direct response. 3.72. What is the ratio of the Claims (% of GDP) of Pacific island small states in 2009 to that in 2011?
Provide a succinct answer. 1.31. What is the ratio of the Claims (% of GDP) of Chile in 2009 to that in 2011?
Provide a short and direct response. 0.32. What is the ratio of the Claims (% of GDP) in Fiji in 2009 to that in 2011?
Your answer should be compact. 1.18. What is the ratio of the Claims (% of GDP) in Caribbean small states in 2009 to that in 2012?
Your answer should be very brief. 0.94. What is the ratio of the Claims (% of GDP) of Pacific island small states in 2009 to that in 2012?
Your answer should be compact. 1.44. What is the ratio of the Claims (% of GDP) in Chile in 2009 to that in 2012?
Offer a very short reply. 0.28. What is the ratio of the Claims (% of GDP) of Fiji in 2009 to that in 2012?
Keep it short and to the point. 1.25. What is the ratio of the Claims (% of GDP) of Caribbean small states in 2009 to that in 2013?
Your answer should be compact. 1.52. What is the ratio of the Claims (% of GDP) in Pacific island small states in 2009 to that in 2013?
Keep it short and to the point. 1.59. What is the ratio of the Claims (% of GDP) in Chile in 2009 to that in 2013?
Keep it short and to the point. 0.24. What is the ratio of the Claims (% of GDP) in Fiji in 2009 to that in 2013?
Offer a terse response. 1.35. What is the ratio of the Claims (% of GDP) of Caribbean small states in 2010 to that in 2011?
Keep it short and to the point. 2.37. What is the ratio of the Claims (% of GDP) of Pacific island small states in 2010 to that in 2011?
Provide a succinct answer. 1.26. What is the ratio of the Claims (% of GDP) of Chile in 2010 to that in 2011?
Offer a very short reply. 0.65. What is the ratio of the Claims (% of GDP) of Fiji in 2010 to that in 2011?
Your answer should be very brief. 1.17. What is the ratio of the Claims (% of GDP) of Caribbean small states in 2010 to that in 2012?
Provide a short and direct response. 0.6. What is the ratio of the Claims (% of GDP) in Pacific island small states in 2010 to that in 2012?
Your response must be concise. 1.39. What is the ratio of the Claims (% of GDP) in Chile in 2010 to that in 2012?
Your answer should be very brief. 0.58. What is the ratio of the Claims (% of GDP) of Fiji in 2010 to that in 2012?
Give a very brief answer. 1.24. What is the ratio of the Claims (% of GDP) in Caribbean small states in 2010 to that in 2013?
Ensure brevity in your answer.  0.97. What is the ratio of the Claims (% of GDP) in Pacific island small states in 2010 to that in 2013?
Provide a succinct answer. 1.53. What is the ratio of the Claims (% of GDP) of Chile in 2010 to that in 2013?
Your response must be concise. 0.49. What is the ratio of the Claims (% of GDP) in Fiji in 2010 to that in 2013?
Provide a short and direct response. 1.34. What is the ratio of the Claims (% of GDP) of Caribbean small states in 2011 to that in 2012?
Give a very brief answer. 0.25. What is the ratio of the Claims (% of GDP) in Pacific island small states in 2011 to that in 2012?
Make the answer very short. 1.11. What is the ratio of the Claims (% of GDP) in Chile in 2011 to that in 2012?
Offer a terse response. 0.89. What is the ratio of the Claims (% of GDP) in Fiji in 2011 to that in 2012?
Your answer should be very brief. 1.06. What is the ratio of the Claims (% of GDP) of Caribbean small states in 2011 to that in 2013?
Your answer should be compact. 0.41. What is the ratio of the Claims (% of GDP) in Pacific island small states in 2011 to that in 2013?
Provide a short and direct response. 1.22. What is the ratio of the Claims (% of GDP) of Chile in 2011 to that in 2013?
Keep it short and to the point. 0.75. What is the ratio of the Claims (% of GDP) of Fiji in 2011 to that in 2013?
Your answer should be very brief. 1.14. What is the ratio of the Claims (% of GDP) in Caribbean small states in 2012 to that in 2013?
Your answer should be very brief. 1.62. What is the ratio of the Claims (% of GDP) of Pacific island small states in 2012 to that in 2013?
Your response must be concise. 1.1. What is the ratio of the Claims (% of GDP) of Chile in 2012 to that in 2013?
Your answer should be compact. 0.85. What is the ratio of the Claims (% of GDP) of Fiji in 2012 to that in 2013?
Make the answer very short. 1.08. What is the difference between the highest and the second highest Claims (% of GDP) of Caribbean small states?
Provide a succinct answer. 0.36. What is the difference between the highest and the second highest Claims (% of GDP) in Pacific island small states?
Keep it short and to the point. 1.69. What is the difference between the highest and the second highest Claims (% of GDP) in Chile?
Offer a terse response. 1.34. What is the difference between the highest and the second highest Claims (% of GDP) of Fiji?
Provide a short and direct response. 0.07. What is the difference between the highest and the lowest Claims (% of GDP) of Caribbean small states?
Your answer should be very brief. 6.05. What is the difference between the highest and the lowest Claims (% of GDP) of Pacific island small states?
Give a very brief answer. 10.44. What is the difference between the highest and the lowest Claims (% of GDP) in Chile?
Your answer should be compact. 7.87. What is the difference between the highest and the lowest Claims (% of GDP) of Fiji?
Offer a very short reply. 10.74. 